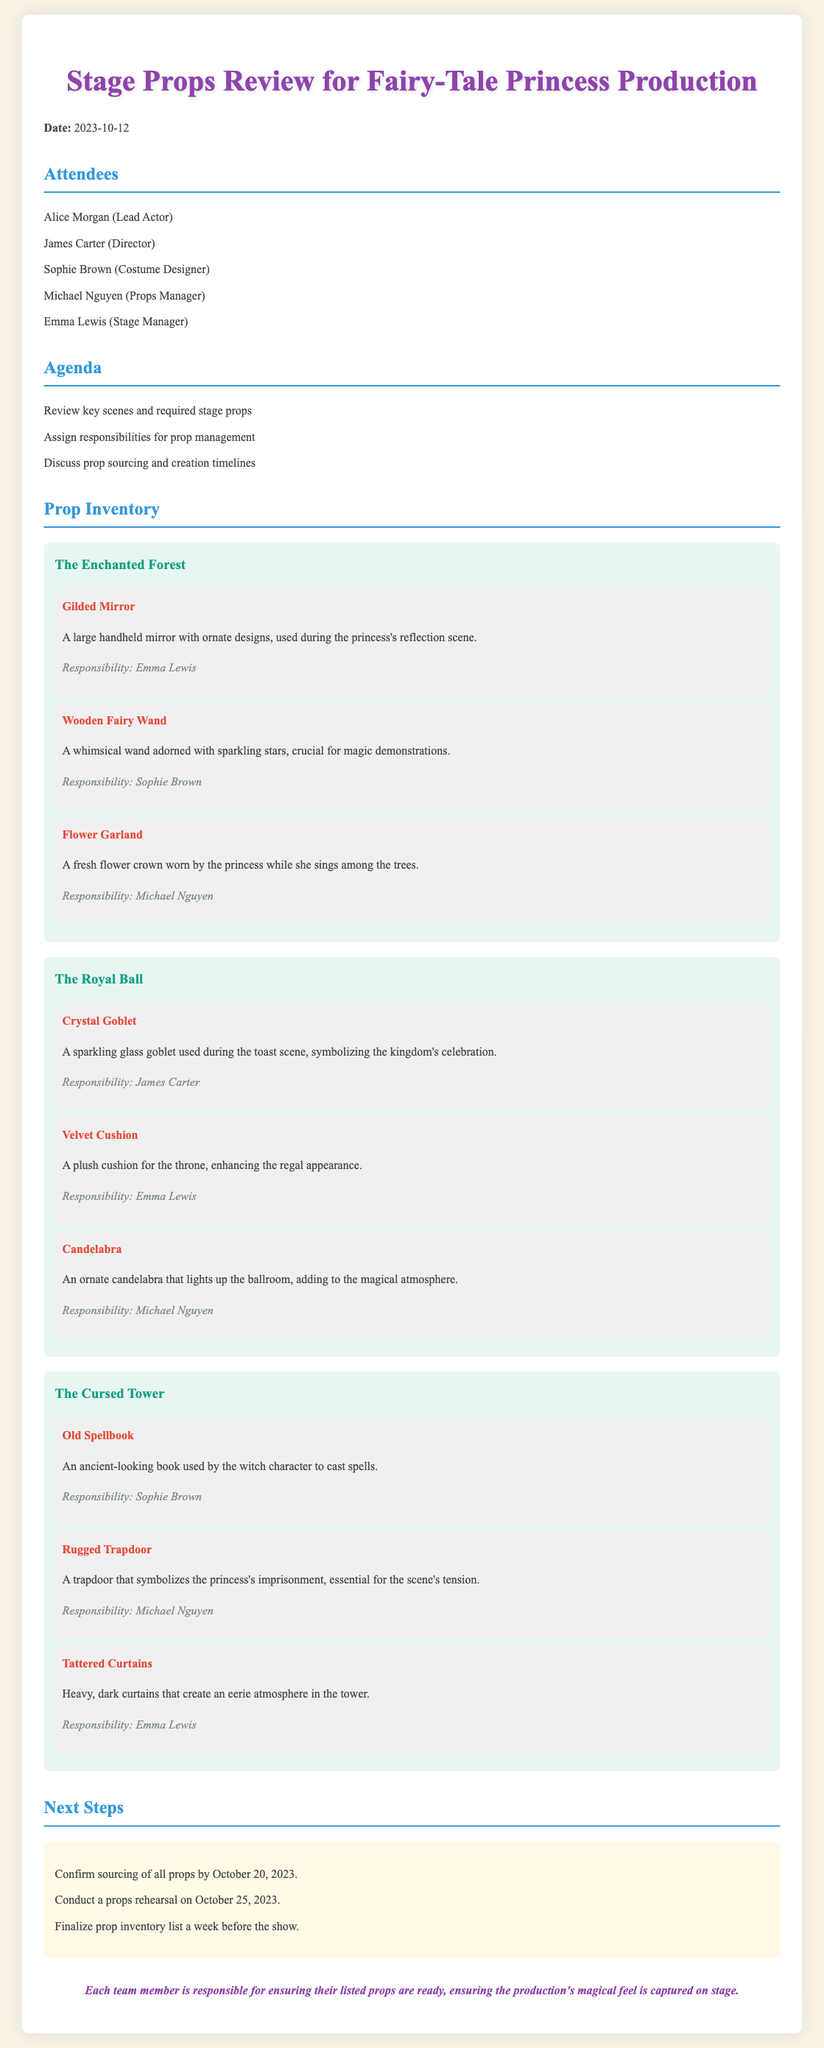What is the date of the meeting? The date of the meeting is stated in the document.
Answer: 2023-10-12 Who is responsible for the Gilded Mirror? The document specifies responsibilities for each prop listed.
Answer: Emma Lewis What is the scene that includes the Crystal Goblet? Each scene is clearly labeled along with their respective props.
Answer: The Royal Ball How many props are listed for The Cursed Tower scene? The document provides an inventory of props for each scene, and they can be counted.
Answer: Three What is the deadline to confirm the sourcing of all props? The timeline for prop sourcing is outlined in the next steps section.
Answer: October 20, 2023 Who is the Props Manager? The attendees list includes the roles of each participant, including the Props Manager.
Answer: Michael Nguyen What type of prop is the Old Spellbook? The document describes the nature of each listed prop in context.
Answer: An ancient-looking book Which scene involves a Flower Garland? Each prop is categorized under its respective scene, making this information clear.
Answer: The Enchanted Forest What is the final action to be taken regarding the prop inventory? The next steps section details the follow-up actions needed before the show.
Answer: Finalize prop inventory list a week before the show 